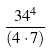<formula> <loc_0><loc_0><loc_500><loc_500>\frac { 3 4 ^ { 4 } } { ( 4 \cdot 7 ) }</formula> 